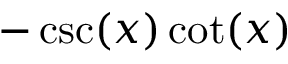Convert formula to latex. <formula><loc_0><loc_0><loc_500><loc_500>- \csc ( x ) \cot ( x )</formula> 